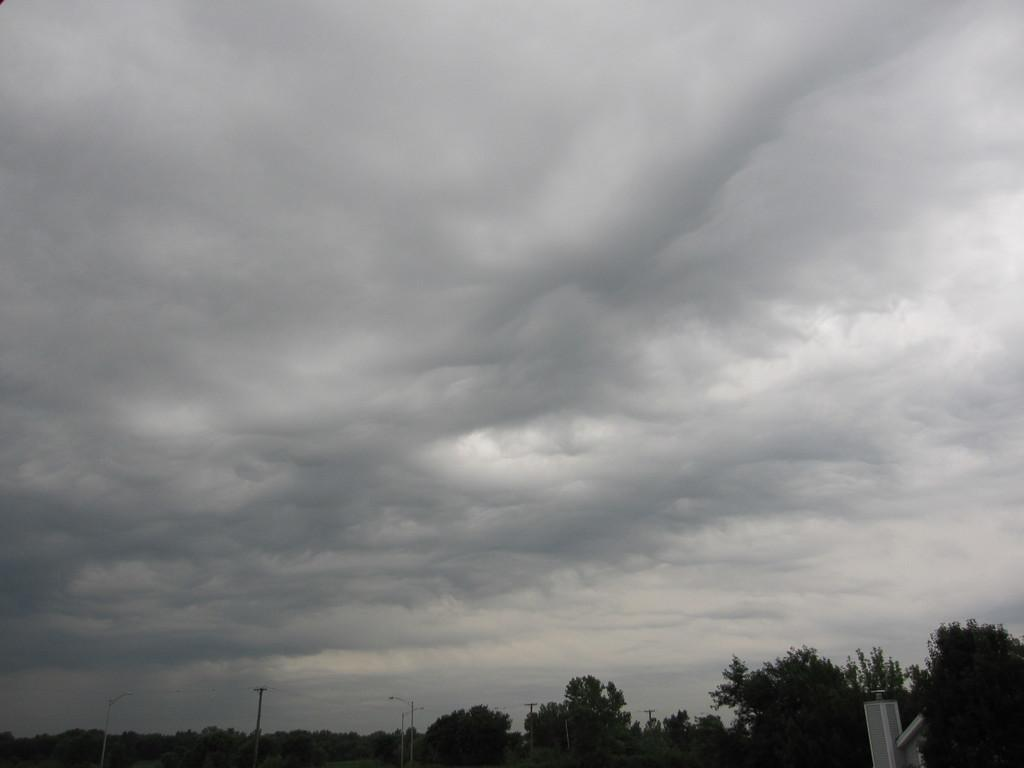What type of vegetation is at the bottom of the image? There are trees at the bottom of the image. What is visible at the top of the image? The sky is visible at the top of the image. Can you describe the sky in the image? The sky appears to be cloudy. How many fish can be seen swimming in the sky in the image? There are no fish visible in the sky in the image. What type of star is present in the trees at the bottom of the image? There are no stars present in the trees at the bottom of the image. 